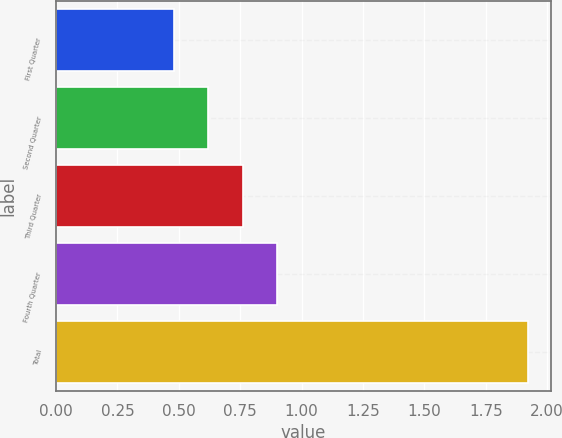Convert chart. <chart><loc_0><loc_0><loc_500><loc_500><bar_chart><fcel>First Quarter<fcel>Second Quarter<fcel>Third Quarter<fcel>Fourth Quarter<fcel>Total<nl><fcel>0.48<fcel>0.62<fcel>0.76<fcel>0.9<fcel>1.92<nl></chart> 